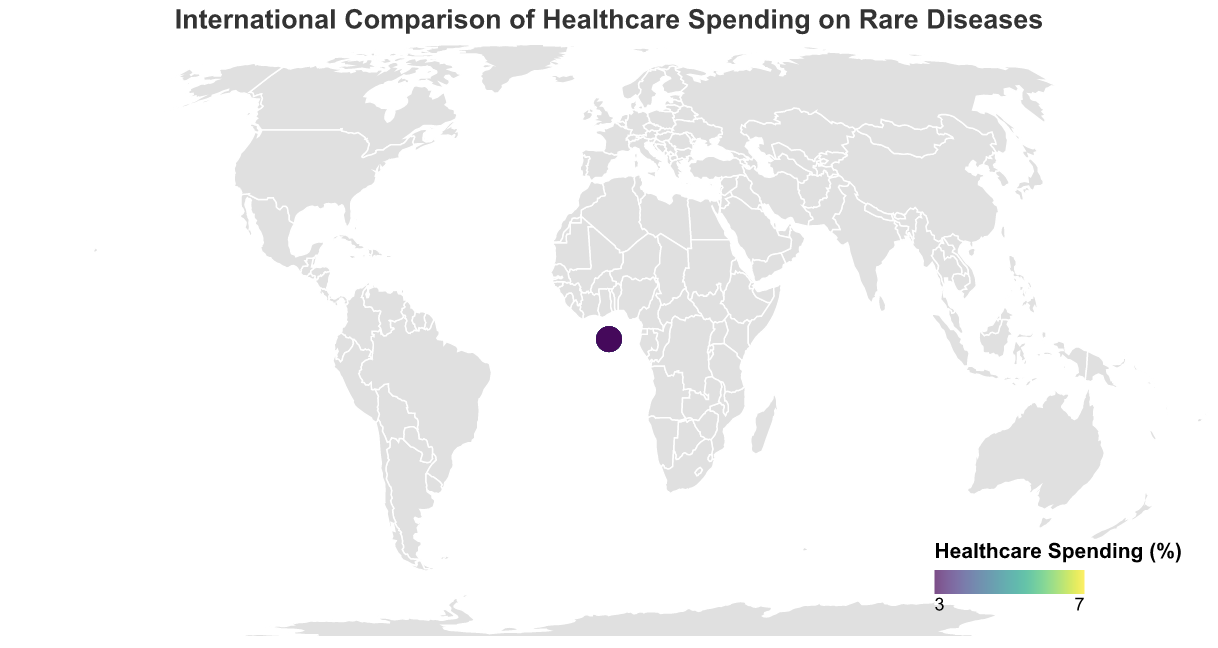What is the title of the figure? The title of the figure is found at the top and it reads "International Comparison of Healthcare Spending on Rare Diseases".
Answer: International Comparison of Healthcare Spending on Rare Diseases Which country has the highest healthcare spending percentage on rare diseases? By looking at the color scale on the map, the United States is colored with the highest intensity on the scale, and the tooltip confirms it has the highest percentage at 7.2%.
Answer: United States How does the healthcare spending percentage on rare diseases in France compare to Germany? France has a healthcare spending percentage of 6.5%, while Germany has 5.9%, as shown by their respective tooltip data. France's percentage is higher.
Answer: France's percentage is higher What is the average healthcare spending percentage on rare diseases for the listed countries? Sum all the percentages (7.2 + 6.8 + 6.5 + 5.9 + 5.6 + 5.3 + 5.1 + 4.8 + 4.5 + 4.2 + 4.0 + 3.8 + 3.6 + 3.4 + 3.2) which equals 74.9, then divide by the number of countries (15). 74.9 / 15 = 4.993.
Answer: 4.993 Which country has the lowest healthcare spending percentage on rare diseases, and what is that percentage? Based on the color scheme and shading intensity, and verified by the tooltip data, Finland has the lowest percentage at 3.2%.
Answer: Finland, 3.2% How many countries have a healthcare spending percentage on rare diseases that is above 5%? Count the countries shown with a percentage above 5%: United States, Netherlands, France, Germany, United Kingdom, Canada, Australia.
Answer: 7 countries What is the difference in healthcare spending percentage between the United States and Italy? The United States has a percentage of 7.2% and Italy has 4.5%. The difference is 7.2% - 4.5% = 2.7%.
Answer: 2.7% Which region (North America, Europe, Asia, etc.) shows the highest variance in healthcare spending percentages on rare diseases? North America with the United States (7.2%) and Canada (5.3%) demonstrates a high variance, specifically it has a variance of (7.2 - 5.3) = 1.9%.
Answer: North America Is there a significant difference between the healthcare spending percentage of Northern European countries (Sweden, Denmark, Norway, Finland) and Southern European countries (Italy, Spain)? Calculate the average for both regions: Northern Europe (4.0 + 3.6 + 3.4 + 3.2) / 4 = 3.55, Southern Europe (4.5 + 4.2) / 2 = 4.35. The difference is 4.35 - 3.55 = 0.8.
Answer: 0.8 Does Japan spend more on rare diseases as a percentage of total healthcare compared to Australia? Japan has a healthcare spending percentage of 4.8%, while Australia has 5.1%. Therefore, Australia spends more.
Answer: No, Australia spends more 